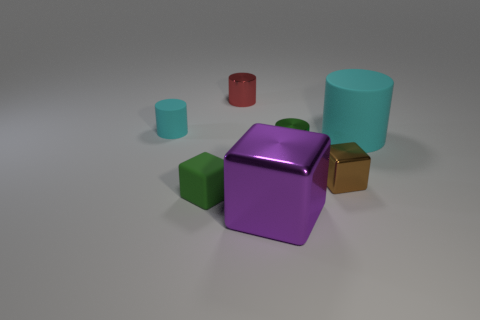What size is the rubber cylinder on the left side of the green cylinder?
Offer a very short reply. Small. How many small cylinders are made of the same material as the small brown block?
Your answer should be compact. 2. Do the cyan object left of the big cyan thing and the red object have the same shape?
Provide a short and direct response. Yes. What color is the cube that is the same material as the purple thing?
Provide a short and direct response. Brown. There is a rubber cylinder that is right of the shiny object to the right of the small green metallic cylinder; are there any red objects behind it?
Make the answer very short. Yes. There is a tiny green rubber object; what shape is it?
Your response must be concise. Cube. Are there fewer brown cubes that are to the right of the tiny green rubber cube than tiny red things?
Your answer should be very brief. No. Is there a small green object of the same shape as the brown object?
Ensure brevity in your answer.  Yes. What shape is the red thing that is the same size as the green shiny thing?
Provide a succinct answer. Cylinder. How many objects are green metallic cylinders or yellow objects?
Provide a short and direct response. 1. 